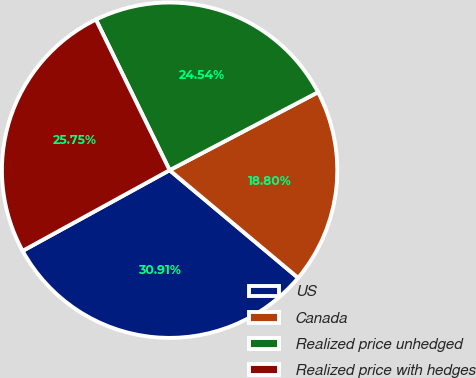<chart> <loc_0><loc_0><loc_500><loc_500><pie_chart><fcel>US<fcel>Canada<fcel>Realized price unhedged<fcel>Realized price with hedges<nl><fcel>30.91%<fcel>18.8%<fcel>24.54%<fcel>25.75%<nl></chart> 